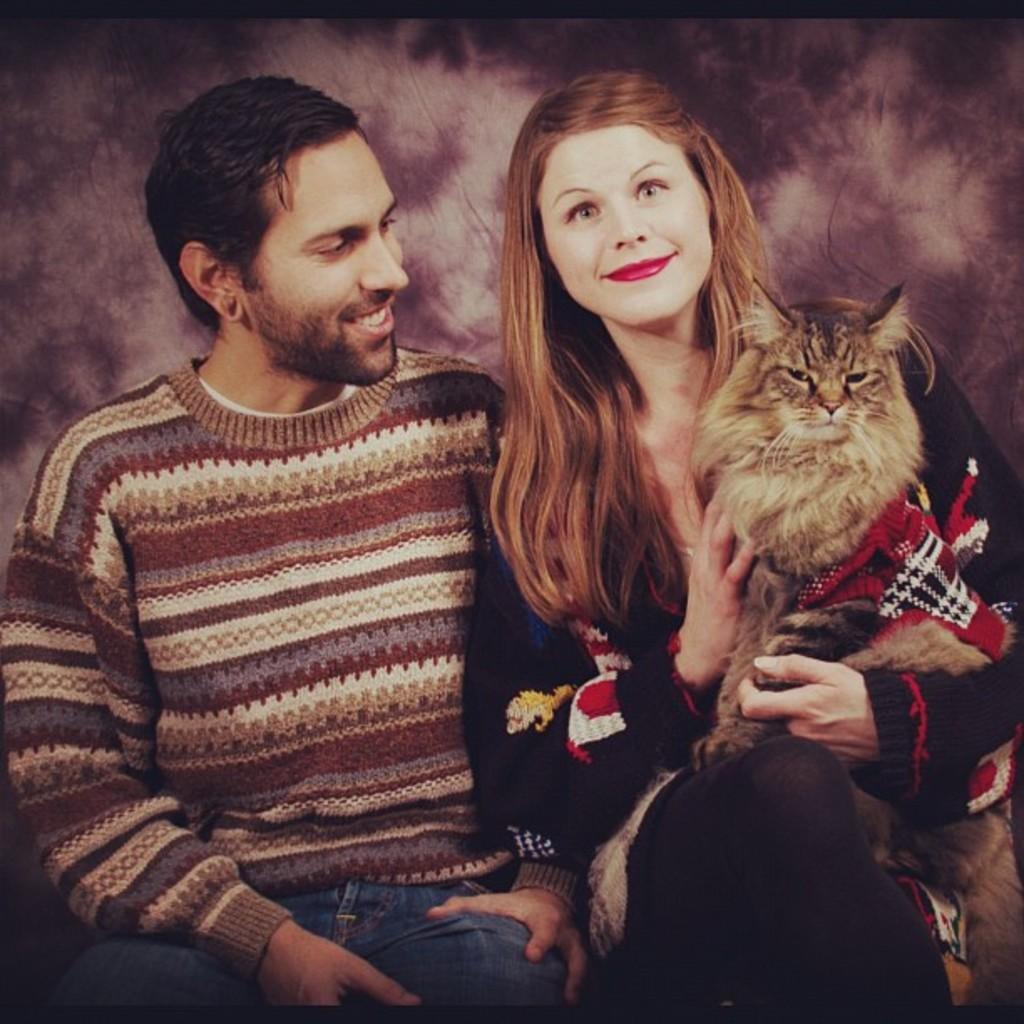In one or two sentences, can you explain what this image depicts? In this picture a man is sitting wearing sweater,behind him another woman is sitting and holding a cat, she is in black dress. 